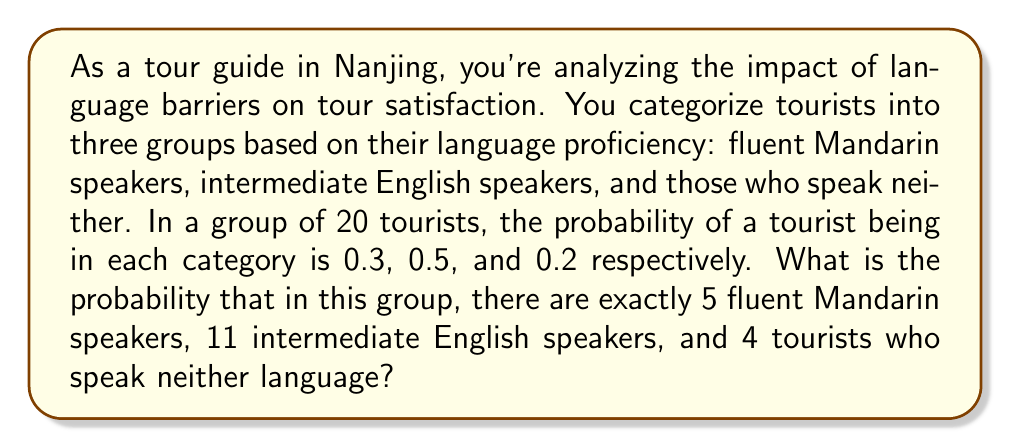Solve this math problem. To solve this problem, we'll use the multinomial distribution, which is appropriate for situations with more than two possible outcomes.

Step 1: Identify the parameters of the multinomial distribution
- Number of trials (tourists): $n = 20$
- Probabilities: $p_1 = 0.3$ (Mandarin), $p_2 = 0.5$ (English), $p_3 = 0.2$ (Neither)
- Counts: $x_1 = 5$ (Mandarin), $x_2 = 11$ (English), $x_3 = 4$ (Neither)

Step 2: Apply the multinomial probability formula
$$P(X_1 = x_1, X_2 = x_2, X_3 = x_3) = \frac{n!}{x_1! x_2! x_3!} p_1^{x_1} p_2^{x_2} p_3^{x_3}$$

Step 3: Substitute the values
$$P(X_1 = 5, X_2 = 11, X_3 = 4) = \frac{20!}{5! 11! 4!} (0.3)^5 (0.5)^{11} (0.2)^4$$

Step 4: Calculate
- $\frac{20!}{5! 11! 4!} = 4,082,925$
- $(0.3)^5 = 0.00243$
- $(0.5)^{11} = 0.00048828125$
- $(0.2)^4 = 0.0016$

Step 5: Multiply all terms
$$4,082,925 \times 0.00243 \times 0.00048828125 \times 0.0016 \approx 0.0077$$

Therefore, the probability is approximately 0.0077 or 0.77%.
Answer: 0.0077 